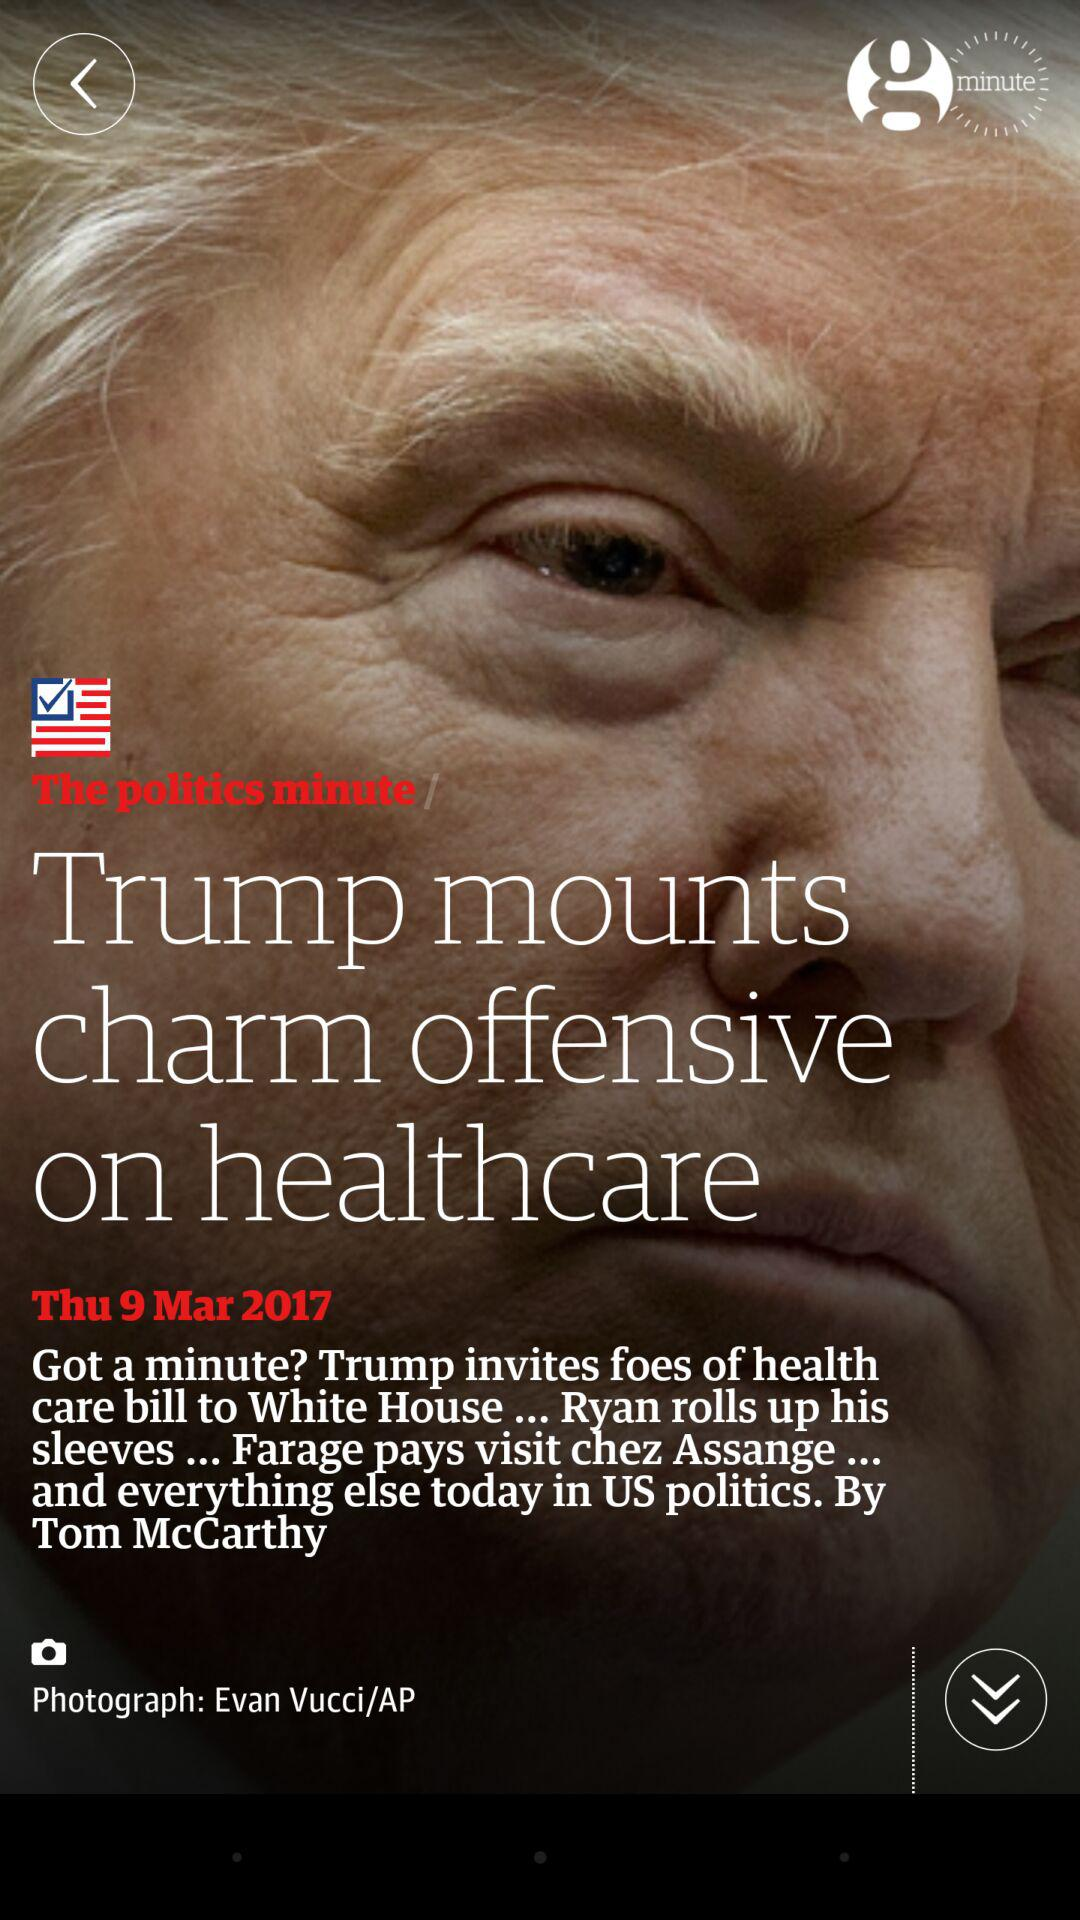What is the publication date? The publication date is Thursday, March 9, 2017. 